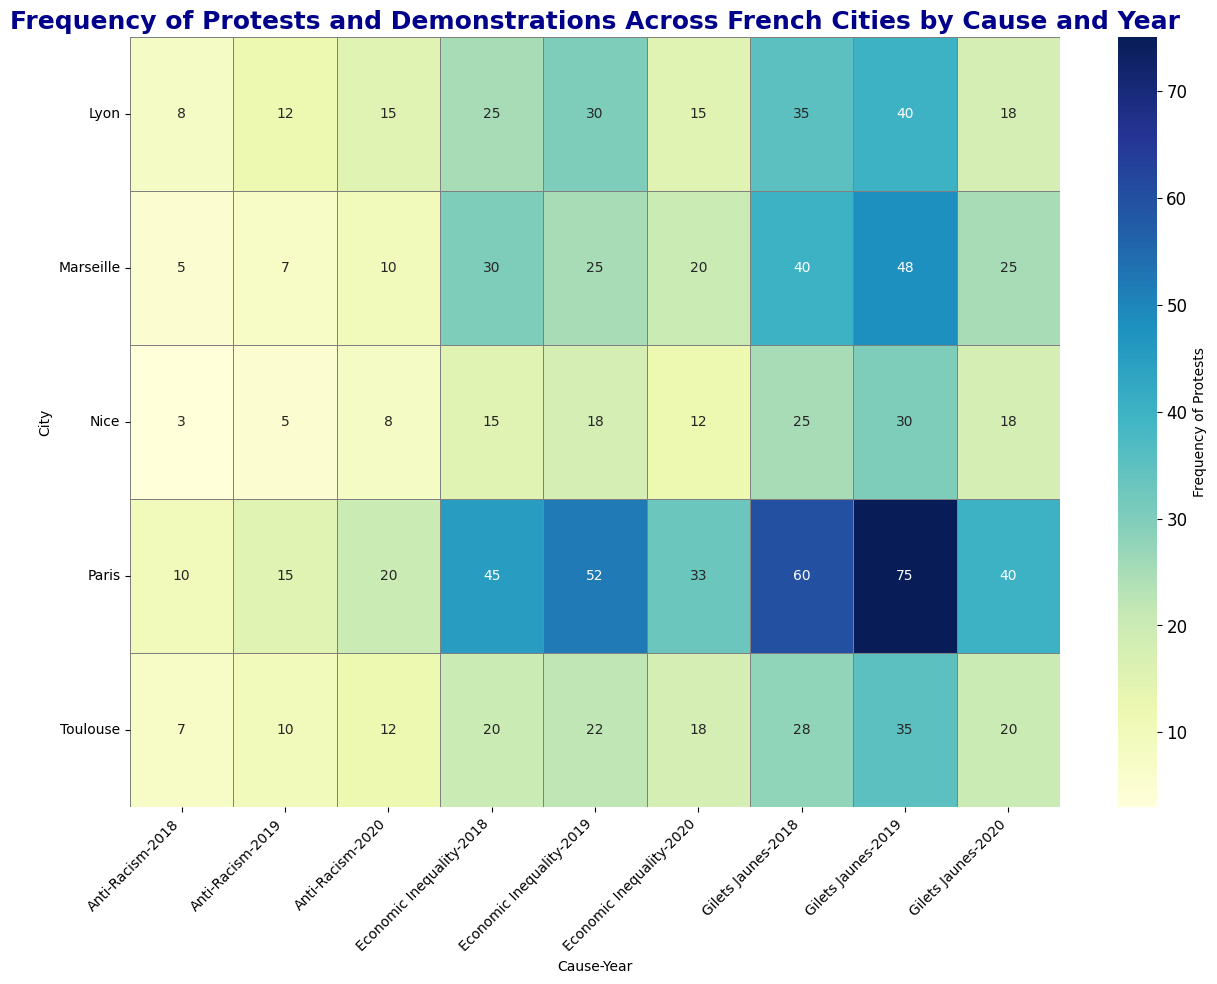What is the most frequent cause of protests in Paris in 2019? Look for the highest frequency value in Paris for the year 2019 across all causes. The frequency for Economic Inequality is 52, Gilets Jaunes is 75, and Anti-Racism is 15. The highest value is for Gilets Jaunes.
Answer: Gilets Jaunes Which city had the highest number of protests against Economic Inequality in 2020? Compare the frequencies of protests against Economic Inequality in 2020 across all cities. Paris has 33, Marseille has 20, Lyon has 15, Toulouse has 18, Nice has 12. The highest number is in Paris.
Answer: Paris How did the frequency of Gilets Jaunes protests in Lyon change from 2018 to 2020? Find the frequencies of Gilets Jaunes protests in Lyon for the years 2018 (35), 2019 (40), and 2020 (18). Notice the decrease from 2018 to 2020.
Answer: Decreased Between which two cities did the frequency of Anti-Racism protests in 2020 differ the most, and what is the difference? Compare the frequencies of Anti-Racism protests in 2020 for all cities: Paris (20), Marseille (10), Lyon (15), Toulouse (12), Nice (8). The maximum difference is between Paris (20) and Nice (8), which is 12.
Answer: Paris and Nice, 12 What was the total number of protests in Marseille in 2019 across all causes? Add the frequencies of all causes in 2019 for Marseille: Economic Inequality (25), Gilets Jaunes (48), Anti-Racism (7). The total is 25 + 48 + 7 = 80.
Answer: 80 In which year did Toulouse see the peak in Gilets Jaunes protests? Compare the frequencies of Gilets Jaunes protests in Toulouse for the years 2018 (28), 2019 (35), and 2020 (20). The peak is in 2019.
Answer: 2019 Which city experienced the lowest frequency of Anti-Racism protests overall across the three years? Compare the total frequencies of Anti-Racism protests for each city across 2018, 2019, and 2020: Paris (45), Marseille (22), Lyon (35), Toulouse (29), Nice (16). The lowest total is in Nice.
Answer: Nice What is the combined frequency of protests for Economic Inequality and Gilets Jaunes in Paris in 2020? Add the frequencies of Economic Inequality (33) and Gilets Jaunes (40) in Paris in 2020. The combined frequency is 33 + 40 = 73.
Answer: 73 